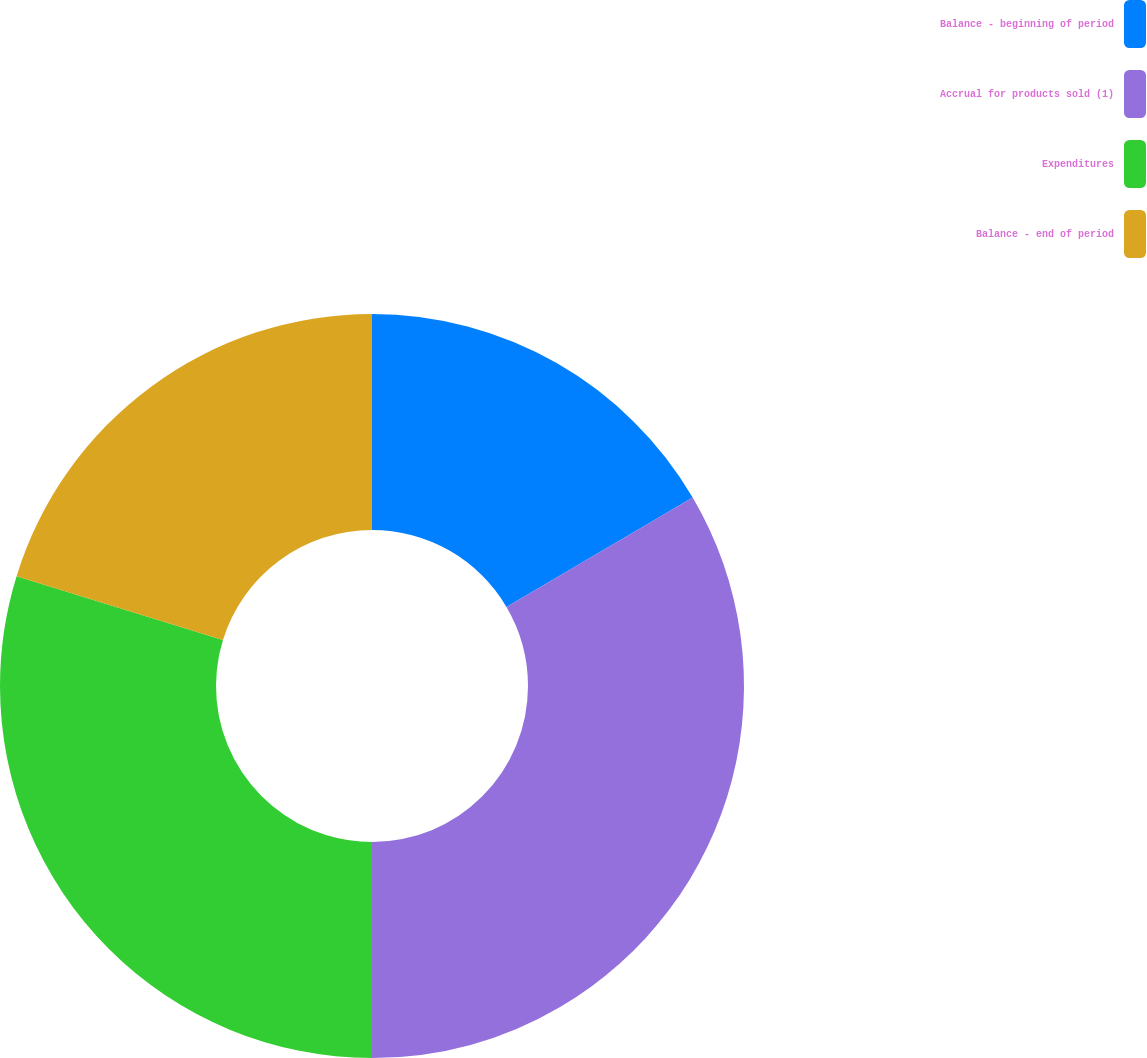<chart> <loc_0><loc_0><loc_500><loc_500><pie_chart><fcel>Balance - beginning of period<fcel>Accrual for products sold (1)<fcel>Expenditures<fcel>Balance - end of period<nl><fcel>16.54%<fcel>33.46%<fcel>29.77%<fcel>20.23%<nl></chart> 